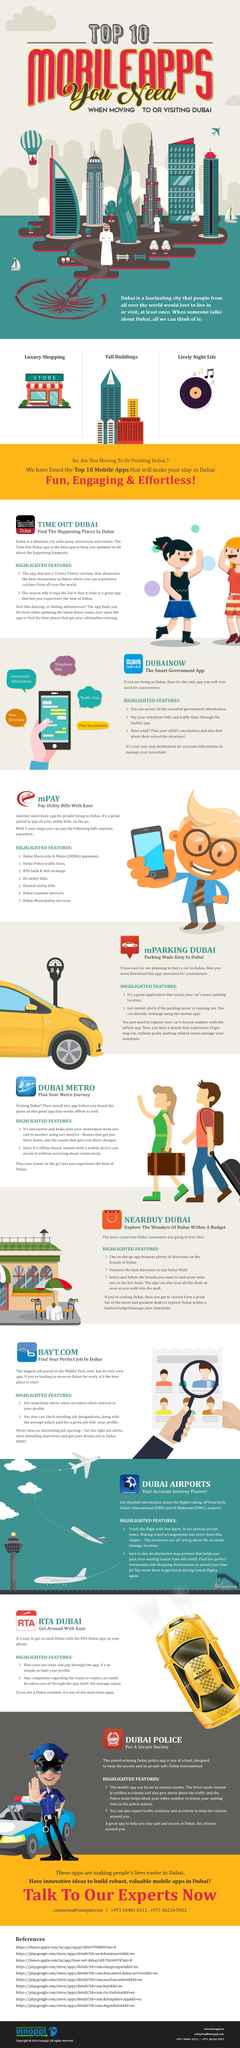Draw attention to some important aspects in this diagram. Dubainow is an app that assists in finding information regarding school fees or vaccinations. The RTA DUBAI app is a useful tool for planning taxi trips, as it enables users to easily hail a ride and track the progress of their journey. The app that aids in discovering faster and more affordable transportation options in Dubai is DUBAI METRO. mPAY is the mobile application that facilitates the payment of electricity and water bills. If you are seeking employment opportunities in Dubai, BAYT.com would be the most helpful app. 